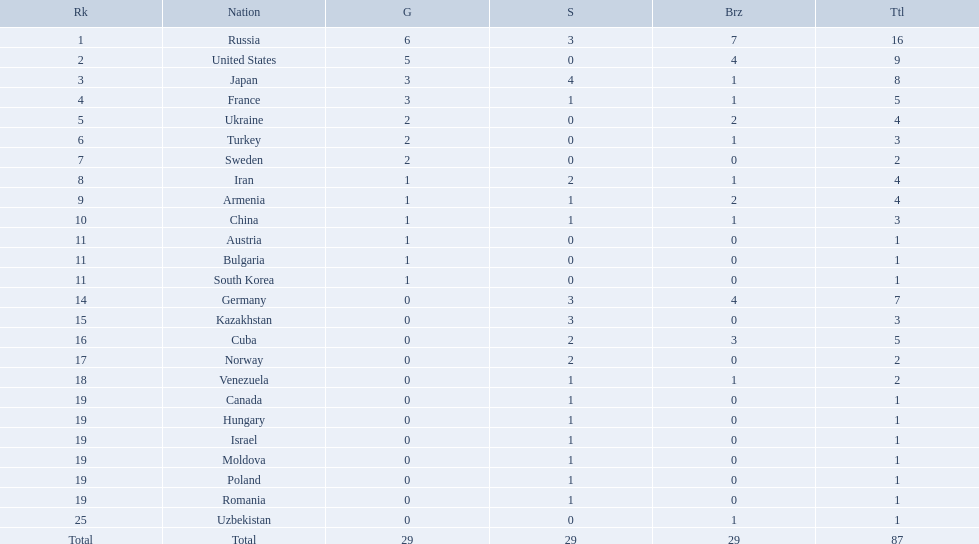How many gold medals did the united states win? 5. Who won more than 5 gold medals? Russia. Which nations participated in the championships? Russia, United States, Japan, France, Ukraine, Turkey, Sweden, Iran, Armenia, China, Austria, Bulgaria, South Korea, Germany, Kazakhstan, Cuba, Norway, Venezuela, Canada, Hungary, Israel, Moldova, Poland, Romania, Uzbekistan. How many bronze medals did they receive? 7, 4, 1, 1, 2, 1, 0, 1, 2, 1, 0, 0, 0, 4, 0, 3, 0, 1, 0, 0, 0, 0, 0, 0, 1, 29. How many in total? 16, 9, 8, 5, 4, 3, 2, 4, 4, 3, 1, 1, 1, 7, 3, 5, 2, 2, 1, 1, 1, 1, 1, 1, 1. And which team won only one medal -- the bronze? Uzbekistan. Which nations have gold medals? Russia, United States, Japan, France, Ukraine, Turkey, Sweden, Iran, Armenia, China, Austria, Bulgaria, South Korea. Of those nations, which have only one gold medal? Iran, Armenia, China, Austria, Bulgaria, South Korea. Write the full table. {'header': ['Rk', 'Nation', 'G', 'S', 'Brz', 'Ttl'], 'rows': [['1', 'Russia', '6', '3', '7', '16'], ['2', 'United States', '5', '0', '4', '9'], ['3', 'Japan', '3', '4', '1', '8'], ['4', 'France', '3', '1', '1', '5'], ['5', 'Ukraine', '2', '0', '2', '4'], ['6', 'Turkey', '2', '0', '1', '3'], ['7', 'Sweden', '2', '0', '0', '2'], ['8', 'Iran', '1', '2', '1', '4'], ['9', 'Armenia', '1', '1', '2', '4'], ['10', 'China', '1', '1', '1', '3'], ['11', 'Austria', '1', '0', '0', '1'], ['11', 'Bulgaria', '1', '0', '0', '1'], ['11', 'South Korea', '1', '0', '0', '1'], ['14', 'Germany', '0', '3', '4', '7'], ['15', 'Kazakhstan', '0', '3', '0', '3'], ['16', 'Cuba', '0', '2', '3', '5'], ['17', 'Norway', '0', '2', '0', '2'], ['18', 'Venezuela', '0', '1', '1', '2'], ['19', 'Canada', '0', '1', '0', '1'], ['19', 'Hungary', '0', '1', '0', '1'], ['19', 'Israel', '0', '1', '0', '1'], ['19', 'Moldova', '0', '1', '0', '1'], ['19', 'Poland', '0', '1', '0', '1'], ['19', 'Romania', '0', '1', '0', '1'], ['25', 'Uzbekistan', '0', '0', '1', '1'], ['Total', 'Total', '29', '29', '29', '87']]} Of those nations, which has no bronze or silver medals? Austria. 